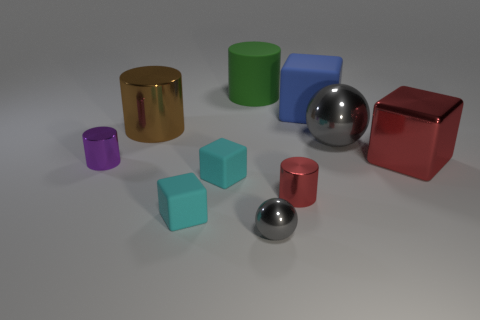Subtract all large metallic cylinders. How many cylinders are left? 3 Subtract all brown cylinders. How many cylinders are left? 3 Subtract 2 cubes. How many cubes are left? 2 Subtract all red balls. How many cyan blocks are left? 2 Subtract 0 cyan balls. How many objects are left? 10 Subtract all spheres. How many objects are left? 8 Subtract all red cylinders. Subtract all purple balls. How many cylinders are left? 3 Subtract all cyan metal blocks. Subtract all large gray spheres. How many objects are left? 9 Add 3 green matte cylinders. How many green matte cylinders are left? 4 Add 2 large yellow matte things. How many large yellow matte things exist? 2 